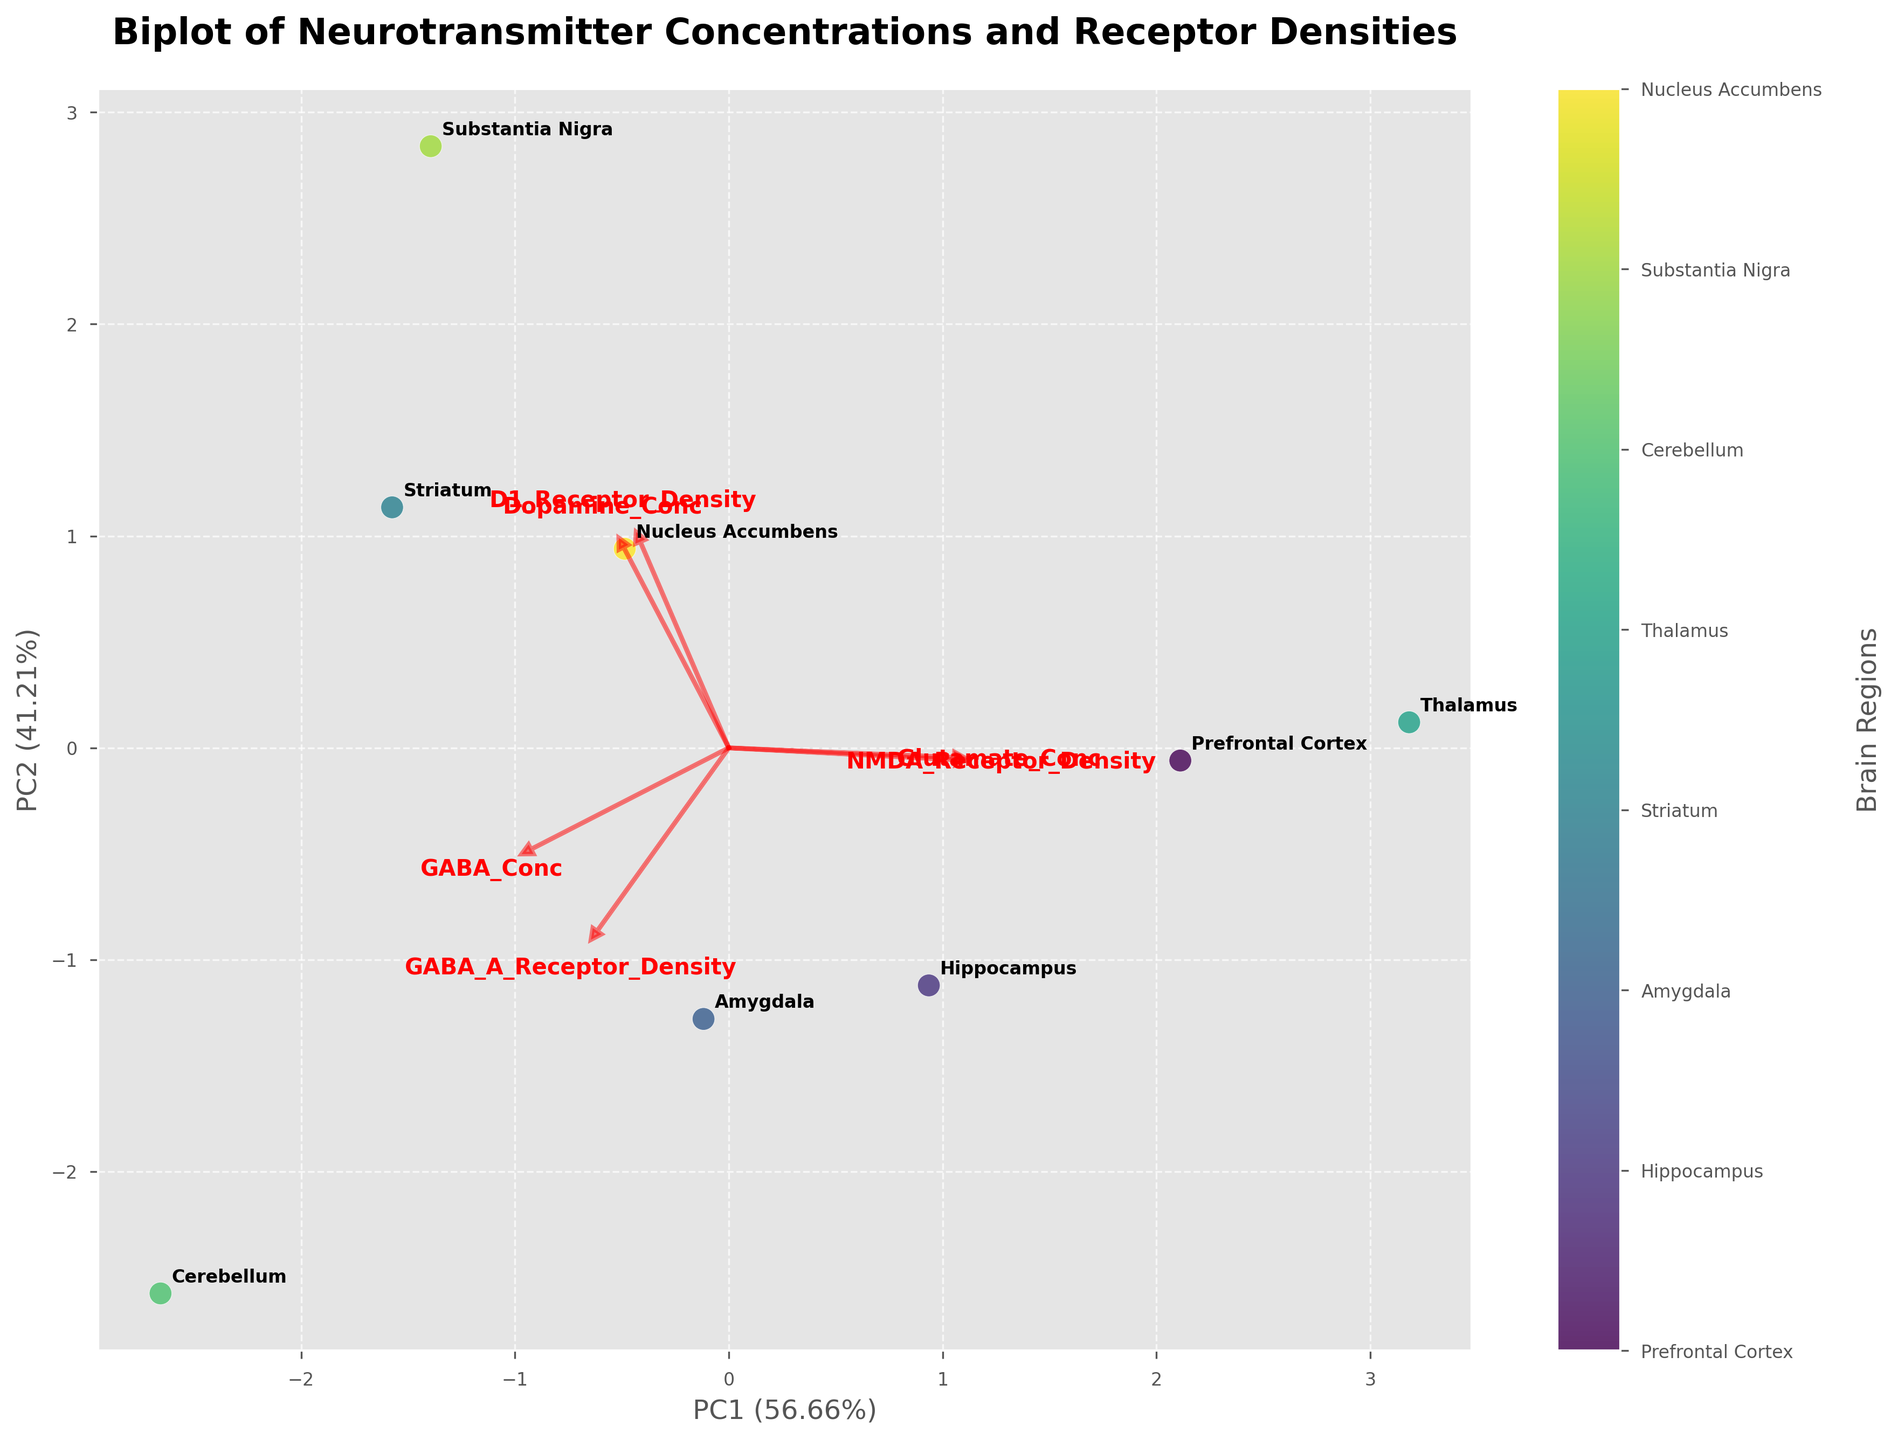What are the axes labeled as? The axes show the principal components from PCA. The X-axis is labeled 'PC1' and the Y-axis is labeled 'PC2', with indicated percentages showing the amount of variance they explain, for instance, 'PC1 (xx.xx%)' and 'PC2 (yy.yy%)'.
Answer: Principal Components PC1 and PC2 Which brain region appears farthest from the origin in the biplot? By examining the spread of data points away from the origin (0,0), the "Substantia Nigra" appears furthest from the origin in the figure.
Answer: Substantia Nigra How many features are represented by loading vectors in the biplot? The number of red arrows (loading vectors) originating from the center (0,0) of the biplot corresponds to the number of features in the data set, which are six (Glutamate Conc, GABA Conc, Dopamine Conc, NMDA Receptor Density, GABA_A Receptor Density, D1 Receptor Density).
Answer: Six Which feature seems to contribute most to PC1? To determine which feature contributes most to PC1, look at the length and direction of the loading vectors along the PC1 axis. The Dopamine Conc (red arrow pointing along PC1 positively or negatively) would be the feature contributing most based on its longer vector extending more in the direction of PC1.
Answer: Dopamine Conc Which two brain regions are closest to each other in the biplot in terms of PC1 and PC2 scores? To find the closest brain regions, check the proximity of the data points in the PCA plot. The "Hippocampus" and "Amygdala" points appear visually closest to each other in the biplot based on their coordinates in the PC1 and PC2 space.
Answer: Hippocampus and Amygdala Are the GABA Concentration and GABA_A Receptor Density vectors positively correlated? Examine the direction of the loading vectors for GABA Conc and GABA_A Receptor Density. If the arrows are oriented in similar directions, they can be considered positively correlated. In the biplot, these vectors do indeed point in similar directions.
Answer: Yes Which principal component explains a higher percentage of variance? The X-axis and Y-axis labels indicate the percentage of variance explained by PC1 and PC2. Compare these percentages to see which is higher. Typically, the label on the X-axis (PC1) explains more variance.
Answer: PC1 What is the approximate percentage of variance explained by the second principal component (PC2)? The Y-axis label provides the percentage of variance explained by PC2, which is included in parentheses next to 'PC2'. For example, it may say 'PC2 (yy.yy%)'.
Answer: Percentage as indicated on PC2 label Which features are closely aligned with PC2? Identify features with loading vectors primarily pointing along the PC2 axis. Those vectors almost parallel to the Y-axis indicate aligned features, such as GABA Conc and NMDA Receptor Density.
Answer: GABA Conc and NMDA Receptor Density 